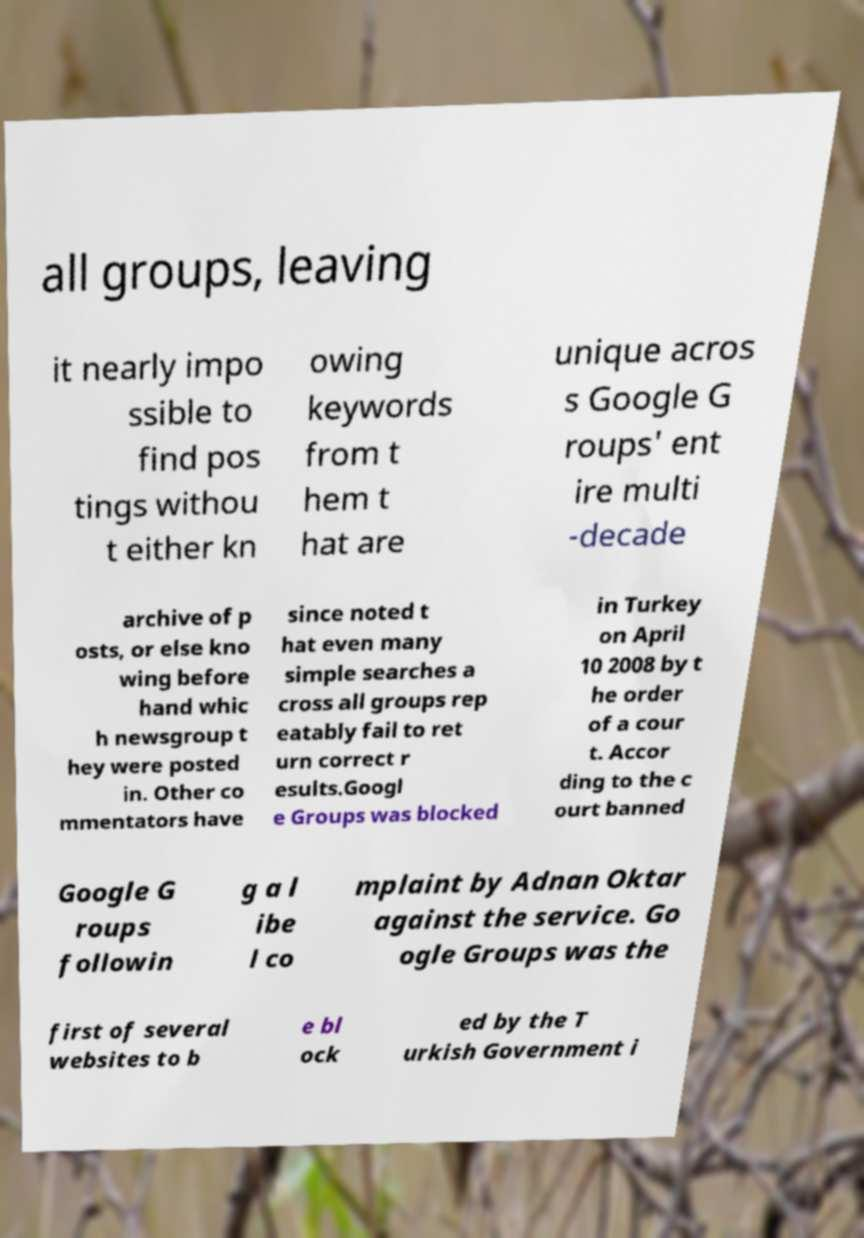For documentation purposes, I need the text within this image transcribed. Could you provide that? all groups, leaving it nearly impo ssible to find pos tings withou t either kn owing keywords from t hem t hat are unique acros s Google G roups' ent ire multi -decade archive of p osts, or else kno wing before hand whic h newsgroup t hey were posted in. Other co mmentators have since noted t hat even many simple searches a cross all groups rep eatably fail to ret urn correct r esults.Googl e Groups was blocked in Turkey on April 10 2008 by t he order of a cour t. Accor ding to the c ourt banned Google G roups followin g a l ibe l co mplaint by Adnan Oktar against the service. Go ogle Groups was the first of several websites to b e bl ock ed by the T urkish Government i 